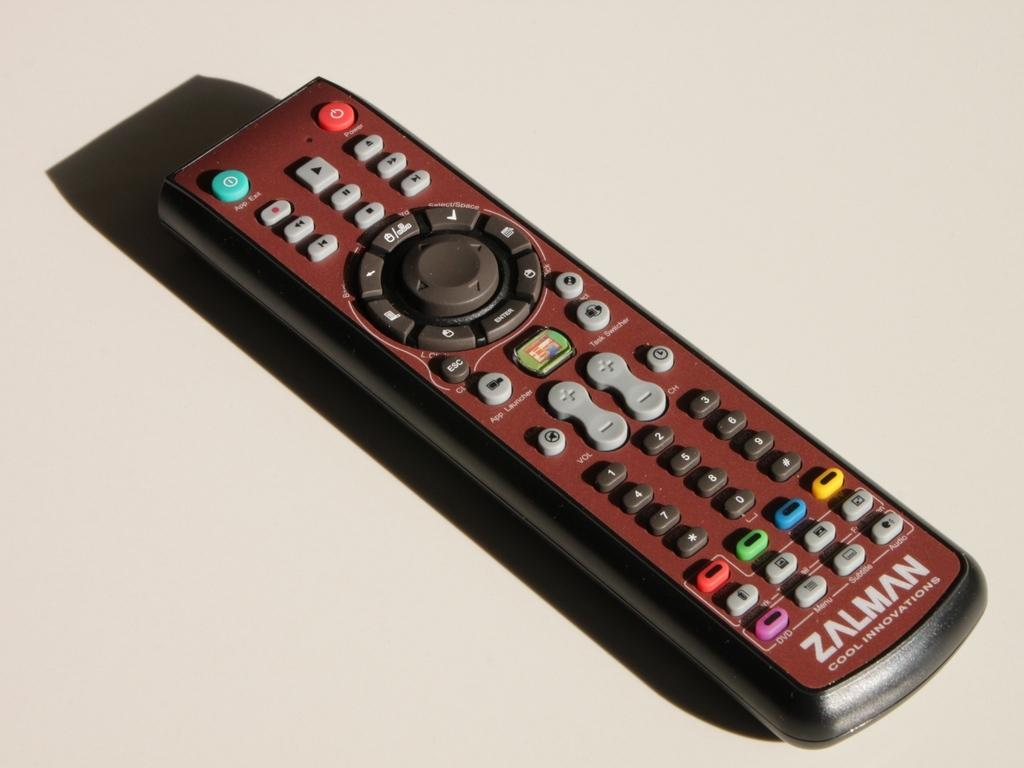<image>
Present a compact description of the photo's key features. A zalman remote control sitting on a white surface with lots of different colored buttons. 